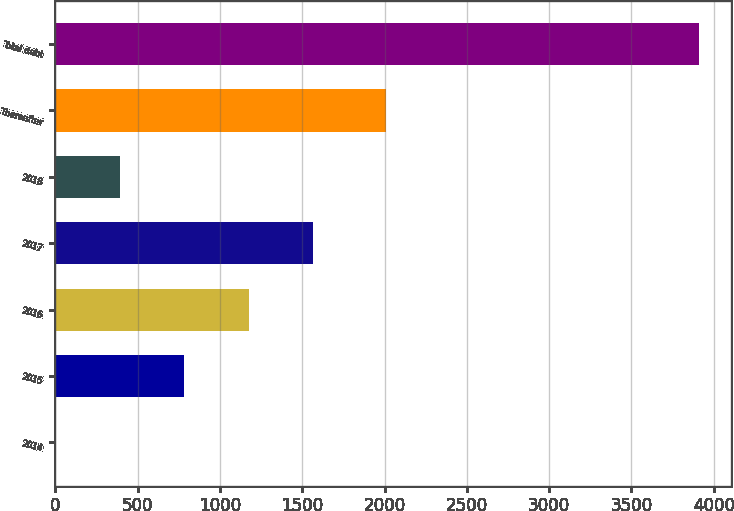<chart> <loc_0><loc_0><loc_500><loc_500><bar_chart><fcel>2014<fcel>2015<fcel>2016<fcel>2017<fcel>2018<fcel>Thereafter<fcel>Total debt<nl><fcel>1<fcel>782.6<fcel>1173.4<fcel>1564.2<fcel>391.8<fcel>2010<fcel>3909<nl></chart> 